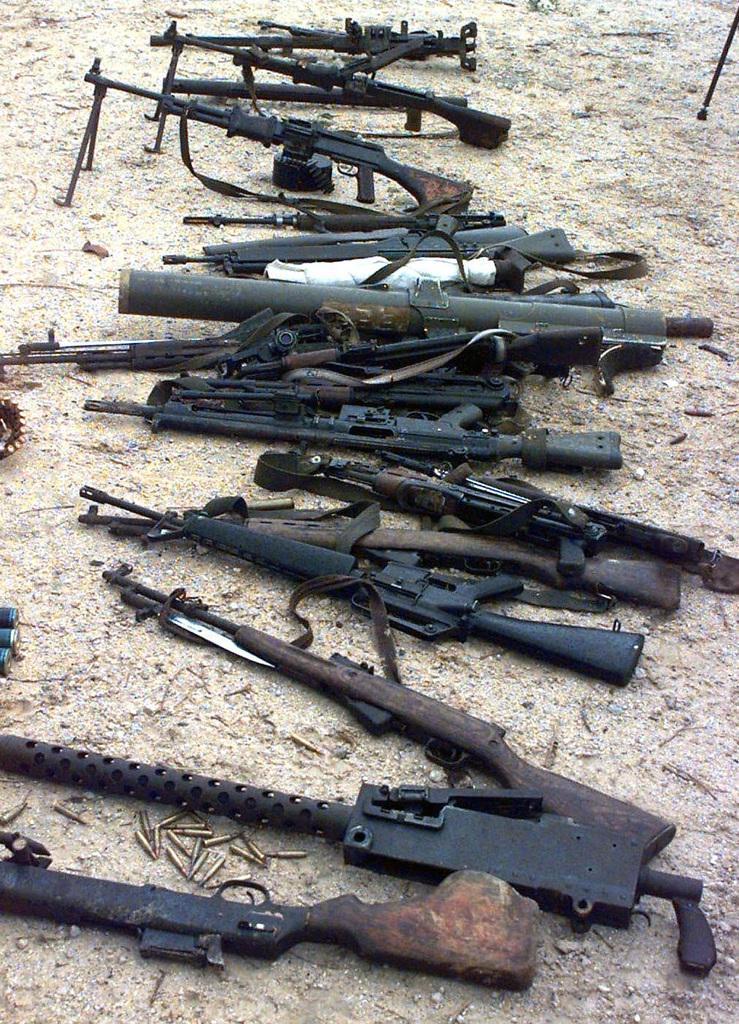Could you give a brief overview of what you see in this image? This picture consists of different types of rifles in the center of the image. 